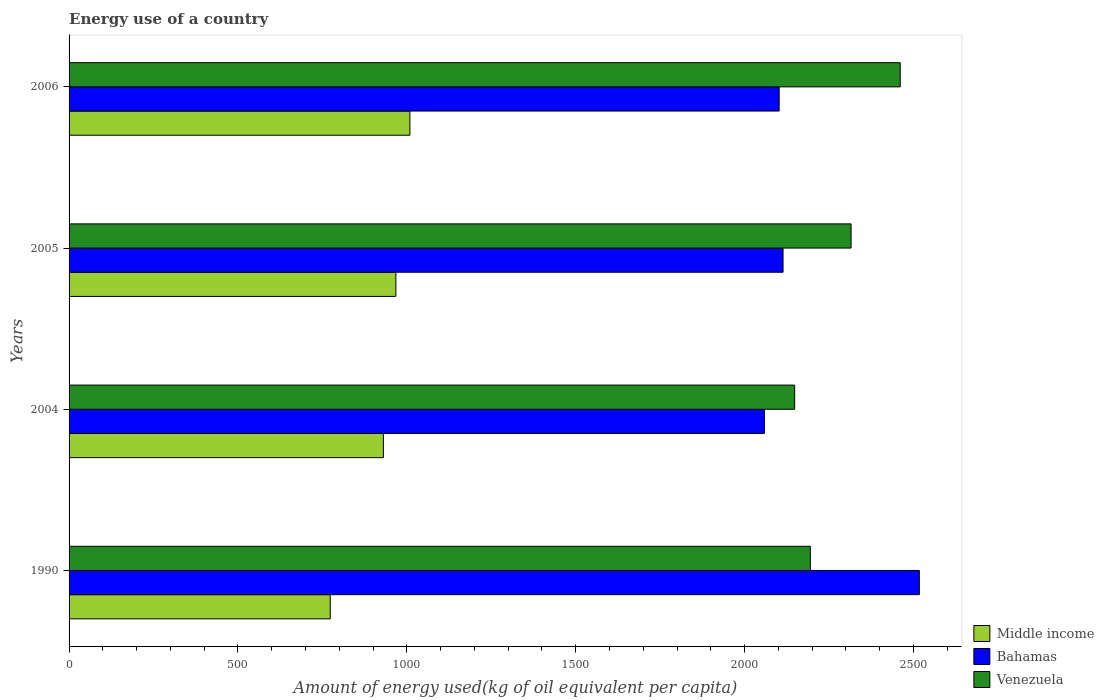What is the label of the 3rd group of bars from the top?
Your answer should be very brief. 2004. In how many cases, is the number of bars for a given year not equal to the number of legend labels?
Provide a short and direct response. 0. What is the amount of energy used in in Middle income in 1990?
Give a very brief answer. 773.25. Across all years, what is the maximum amount of energy used in in Venezuela?
Ensure brevity in your answer.  2460.81. Across all years, what is the minimum amount of energy used in in Bahamas?
Give a very brief answer. 2058.67. In which year was the amount of energy used in in Middle income maximum?
Make the answer very short. 2006. In which year was the amount of energy used in in Venezuela minimum?
Offer a terse response. 2004. What is the total amount of energy used in in Venezuela in the graph?
Your answer should be compact. 9119.11. What is the difference between the amount of energy used in in Middle income in 1990 and that in 2004?
Offer a very short reply. -157.37. What is the difference between the amount of energy used in in Venezuela in 1990 and the amount of energy used in in Bahamas in 2005?
Provide a short and direct response. 80.77. What is the average amount of energy used in in Venezuela per year?
Your answer should be compact. 2279.78. In the year 2004, what is the difference between the amount of energy used in in Middle income and amount of energy used in in Venezuela?
Offer a terse response. -1217.68. What is the ratio of the amount of energy used in in Bahamas in 1990 to that in 2006?
Ensure brevity in your answer.  1.2. Is the amount of energy used in in Bahamas in 1990 less than that in 2006?
Give a very brief answer. No. What is the difference between the highest and the second highest amount of energy used in in Middle income?
Give a very brief answer. 41.58. What is the difference between the highest and the lowest amount of energy used in in Middle income?
Offer a very short reply. 235.9. In how many years, is the amount of energy used in in Venezuela greater than the average amount of energy used in in Venezuela taken over all years?
Make the answer very short. 2. Is the sum of the amount of energy used in in Venezuela in 2004 and 2006 greater than the maximum amount of energy used in in Bahamas across all years?
Your answer should be compact. Yes. What does the 2nd bar from the top in 2005 represents?
Give a very brief answer. Bahamas. What does the 3rd bar from the bottom in 1990 represents?
Your response must be concise. Venezuela. How many bars are there?
Offer a terse response. 12. Are all the bars in the graph horizontal?
Give a very brief answer. Yes. Are the values on the major ticks of X-axis written in scientific E-notation?
Ensure brevity in your answer.  No. Does the graph contain any zero values?
Provide a succinct answer. No. Where does the legend appear in the graph?
Give a very brief answer. Bottom right. How many legend labels are there?
Offer a terse response. 3. What is the title of the graph?
Offer a very short reply. Energy use of a country. What is the label or title of the X-axis?
Your response must be concise. Amount of energy used(kg of oil equivalent per capita). What is the label or title of the Y-axis?
Offer a terse response. Years. What is the Amount of energy used(kg of oil equivalent per capita) in Middle income in 1990?
Keep it short and to the point. 773.25. What is the Amount of energy used(kg of oil equivalent per capita) of Bahamas in 1990?
Your answer should be compact. 2517.45. What is the Amount of energy used(kg of oil equivalent per capita) in Venezuela in 1990?
Make the answer very short. 2194.71. What is the Amount of energy used(kg of oil equivalent per capita) of Middle income in 2004?
Give a very brief answer. 930.62. What is the Amount of energy used(kg of oil equivalent per capita) in Bahamas in 2004?
Make the answer very short. 2058.67. What is the Amount of energy used(kg of oil equivalent per capita) of Venezuela in 2004?
Provide a short and direct response. 2148.3. What is the Amount of energy used(kg of oil equivalent per capita) of Middle income in 2005?
Offer a terse response. 967.58. What is the Amount of energy used(kg of oil equivalent per capita) of Bahamas in 2005?
Ensure brevity in your answer.  2113.94. What is the Amount of energy used(kg of oil equivalent per capita) in Venezuela in 2005?
Your response must be concise. 2315.3. What is the Amount of energy used(kg of oil equivalent per capita) in Middle income in 2006?
Offer a very short reply. 1009.15. What is the Amount of energy used(kg of oil equivalent per capita) in Bahamas in 2006?
Keep it short and to the point. 2102.44. What is the Amount of energy used(kg of oil equivalent per capita) in Venezuela in 2006?
Your response must be concise. 2460.81. Across all years, what is the maximum Amount of energy used(kg of oil equivalent per capita) in Middle income?
Offer a very short reply. 1009.15. Across all years, what is the maximum Amount of energy used(kg of oil equivalent per capita) of Bahamas?
Make the answer very short. 2517.45. Across all years, what is the maximum Amount of energy used(kg of oil equivalent per capita) in Venezuela?
Offer a terse response. 2460.81. Across all years, what is the minimum Amount of energy used(kg of oil equivalent per capita) in Middle income?
Your response must be concise. 773.25. Across all years, what is the minimum Amount of energy used(kg of oil equivalent per capita) in Bahamas?
Ensure brevity in your answer.  2058.67. Across all years, what is the minimum Amount of energy used(kg of oil equivalent per capita) in Venezuela?
Give a very brief answer. 2148.3. What is the total Amount of energy used(kg of oil equivalent per capita) of Middle income in the graph?
Ensure brevity in your answer.  3680.59. What is the total Amount of energy used(kg of oil equivalent per capita) of Bahamas in the graph?
Keep it short and to the point. 8792.49. What is the total Amount of energy used(kg of oil equivalent per capita) in Venezuela in the graph?
Make the answer very short. 9119.11. What is the difference between the Amount of energy used(kg of oil equivalent per capita) of Middle income in 1990 and that in 2004?
Offer a terse response. -157.37. What is the difference between the Amount of energy used(kg of oil equivalent per capita) in Bahamas in 1990 and that in 2004?
Give a very brief answer. 458.78. What is the difference between the Amount of energy used(kg of oil equivalent per capita) of Venezuela in 1990 and that in 2004?
Provide a succinct answer. 46.41. What is the difference between the Amount of energy used(kg of oil equivalent per capita) of Middle income in 1990 and that in 2005?
Provide a succinct answer. -194.33. What is the difference between the Amount of energy used(kg of oil equivalent per capita) in Bahamas in 1990 and that in 2005?
Offer a terse response. 403.51. What is the difference between the Amount of energy used(kg of oil equivalent per capita) of Venezuela in 1990 and that in 2005?
Your response must be concise. -120.59. What is the difference between the Amount of energy used(kg of oil equivalent per capita) in Middle income in 1990 and that in 2006?
Provide a succinct answer. -235.9. What is the difference between the Amount of energy used(kg of oil equivalent per capita) in Bahamas in 1990 and that in 2006?
Offer a very short reply. 415.01. What is the difference between the Amount of energy used(kg of oil equivalent per capita) of Venezuela in 1990 and that in 2006?
Offer a terse response. -266.1. What is the difference between the Amount of energy used(kg of oil equivalent per capita) of Middle income in 2004 and that in 2005?
Give a very brief answer. -36.96. What is the difference between the Amount of energy used(kg of oil equivalent per capita) of Bahamas in 2004 and that in 2005?
Provide a succinct answer. -55.27. What is the difference between the Amount of energy used(kg of oil equivalent per capita) in Venezuela in 2004 and that in 2005?
Give a very brief answer. -167. What is the difference between the Amount of energy used(kg of oil equivalent per capita) in Middle income in 2004 and that in 2006?
Provide a succinct answer. -78.53. What is the difference between the Amount of energy used(kg of oil equivalent per capita) of Bahamas in 2004 and that in 2006?
Provide a short and direct response. -43.77. What is the difference between the Amount of energy used(kg of oil equivalent per capita) in Venezuela in 2004 and that in 2006?
Provide a short and direct response. -312.51. What is the difference between the Amount of energy used(kg of oil equivalent per capita) in Middle income in 2005 and that in 2006?
Provide a short and direct response. -41.58. What is the difference between the Amount of energy used(kg of oil equivalent per capita) in Bahamas in 2005 and that in 2006?
Provide a short and direct response. 11.5. What is the difference between the Amount of energy used(kg of oil equivalent per capita) in Venezuela in 2005 and that in 2006?
Your answer should be compact. -145.51. What is the difference between the Amount of energy used(kg of oil equivalent per capita) of Middle income in 1990 and the Amount of energy used(kg of oil equivalent per capita) of Bahamas in 2004?
Ensure brevity in your answer.  -1285.42. What is the difference between the Amount of energy used(kg of oil equivalent per capita) of Middle income in 1990 and the Amount of energy used(kg of oil equivalent per capita) of Venezuela in 2004?
Provide a succinct answer. -1375.05. What is the difference between the Amount of energy used(kg of oil equivalent per capita) in Bahamas in 1990 and the Amount of energy used(kg of oil equivalent per capita) in Venezuela in 2004?
Provide a short and direct response. 369.15. What is the difference between the Amount of energy used(kg of oil equivalent per capita) in Middle income in 1990 and the Amount of energy used(kg of oil equivalent per capita) in Bahamas in 2005?
Your answer should be compact. -1340.69. What is the difference between the Amount of energy used(kg of oil equivalent per capita) of Middle income in 1990 and the Amount of energy used(kg of oil equivalent per capita) of Venezuela in 2005?
Offer a very short reply. -1542.05. What is the difference between the Amount of energy used(kg of oil equivalent per capita) of Bahamas in 1990 and the Amount of energy used(kg of oil equivalent per capita) of Venezuela in 2005?
Offer a very short reply. 202.15. What is the difference between the Amount of energy used(kg of oil equivalent per capita) in Middle income in 1990 and the Amount of energy used(kg of oil equivalent per capita) in Bahamas in 2006?
Keep it short and to the point. -1329.19. What is the difference between the Amount of energy used(kg of oil equivalent per capita) in Middle income in 1990 and the Amount of energy used(kg of oil equivalent per capita) in Venezuela in 2006?
Your answer should be very brief. -1687.56. What is the difference between the Amount of energy used(kg of oil equivalent per capita) of Bahamas in 1990 and the Amount of energy used(kg of oil equivalent per capita) of Venezuela in 2006?
Keep it short and to the point. 56.64. What is the difference between the Amount of energy used(kg of oil equivalent per capita) in Middle income in 2004 and the Amount of energy used(kg of oil equivalent per capita) in Bahamas in 2005?
Ensure brevity in your answer.  -1183.32. What is the difference between the Amount of energy used(kg of oil equivalent per capita) of Middle income in 2004 and the Amount of energy used(kg of oil equivalent per capita) of Venezuela in 2005?
Make the answer very short. -1384.68. What is the difference between the Amount of energy used(kg of oil equivalent per capita) of Bahamas in 2004 and the Amount of energy used(kg of oil equivalent per capita) of Venezuela in 2005?
Offer a very short reply. -256.63. What is the difference between the Amount of energy used(kg of oil equivalent per capita) in Middle income in 2004 and the Amount of energy used(kg of oil equivalent per capita) in Bahamas in 2006?
Provide a succinct answer. -1171.82. What is the difference between the Amount of energy used(kg of oil equivalent per capita) in Middle income in 2004 and the Amount of energy used(kg of oil equivalent per capita) in Venezuela in 2006?
Offer a very short reply. -1530.19. What is the difference between the Amount of energy used(kg of oil equivalent per capita) of Bahamas in 2004 and the Amount of energy used(kg of oil equivalent per capita) of Venezuela in 2006?
Make the answer very short. -402.14. What is the difference between the Amount of energy used(kg of oil equivalent per capita) of Middle income in 2005 and the Amount of energy used(kg of oil equivalent per capita) of Bahamas in 2006?
Your response must be concise. -1134.86. What is the difference between the Amount of energy used(kg of oil equivalent per capita) of Middle income in 2005 and the Amount of energy used(kg of oil equivalent per capita) of Venezuela in 2006?
Your answer should be very brief. -1493.23. What is the difference between the Amount of energy used(kg of oil equivalent per capita) in Bahamas in 2005 and the Amount of energy used(kg of oil equivalent per capita) in Venezuela in 2006?
Offer a very short reply. -346.87. What is the average Amount of energy used(kg of oil equivalent per capita) of Middle income per year?
Provide a short and direct response. 920.15. What is the average Amount of energy used(kg of oil equivalent per capita) of Bahamas per year?
Provide a short and direct response. 2198.12. What is the average Amount of energy used(kg of oil equivalent per capita) in Venezuela per year?
Your answer should be very brief. 2279.78. In the year 1990, what is the difference between the Amount of energy used(kg of oil equivalent per capita) of Middle income and Amount of energy used(kg of oil equivalent per capita) of Bahamas?
Provide a short and direct response. -1744.2. In the year 1990, what is the difference between the Amount of energy used(kg of oil equivalent per capita) in Middle income and Amount of energy used(kg of oil equivalent per capita) in Venezuela?
Offer a very short reply. -1421.46. In the year 1990, what is the difference between the Amount of energy used(kg of oil equivalent per capita) of Bahamas and Amount of energy used(kg of oil equivalent per capita) of Venezuela?
Provide a short and direct response. 322.74. In the year 2004, what is the difference between the Amount of energy used(kg of oil equivalent per capita) in Middle income and Amount of energy used(kg of oil equivalent per capita) in Bahamas?
Keep it short and to the point. -1128.05. In the year 2004, what is the difference between the Amount of energy used(kg of oil equivalent per capita) of Middle income and Amount of energy used(kg of oil equivalent per capita) of Venezuela?
Give a very brief answer. -1217.68. In the year 2004, what is the difference between the Amount of energy used(kg of oil equivalent per capita) of Bahamas and Amount of energy used(kg of oil equivalent per capita) of Venezuela?
Offer a terse response. -89.63. In the year 2005, what is the difference between the Amount of energy used(kg of oil equivalent per capita) of Middle income and Amount of energy used(kg of oil equivalent per capita) of Bahamas?
Your answer should be compact. -1146.37. In the year 2005, what is the difference between the Amount of energy used(kg of oil equivalent per capita) of Middle income and Amount of energy used(kg of oil equivalent per capita) of Venezuela?
Give a very brief answer. -1347.72. In the year 2005, what is the difference between the Amount of energy used(kg of oil equivalent per capita) of Bahamas and Amount of energy used(kg of oil equivalent per capita) of Venezuela?
Your answer should be very brief. -201.36. In the year 2006, what is the difference between the Amount of energy used(kg of oil equivalent per capita) of Middle income and Amount of energy used(kg of oil equivalent per capita) of Bahamas?
Offer a terse response. -1093.29. In the year 2006, what is the difference between the Amount of energy used(kg of oil equivalent per capita) of Middle income and Amount of energy used(kg of oil equivalent per capita) of Venezuela?
Provide a succinct answer. -1451.66. In the year 2006, what is the difference between the Amount of energy used(kg of oil equivalent per capita) in Bahamas and Amount of energy used(kg of oil equivalent per capita) in Venezuela?
Provide a short and direct response. -358.37. What is the ratio of the Amount of energy used(kg of oil equivalent per capita) in Middle income in 1990 to that in 2004?
Offer a very short reply. 0.83. What is the ratio of the Amount of energy used(kg of oil equivalent per capita) in Bahamas in 1990 to that in 2004?
Keep it short and to the point. 1.22. What is the ratio of the Amount of energy used(kg of oil equivalent per capita) of Venezuela in 1990 to that in 2004?
Ensure brevity in your answer.  1.02. What is the ratio of the Amount of energy used(kg of oil equivalent per capita) in Middle income in 1990 to that in 2005?
Your response must be concise. 0.8. What is the ratio of the Amount of energy used(kg of oil equivalent per capita) of Bahamas in 1990 to that in 2005?
Your answer should be very brief. 1.19. What is the ratio of the Amount of energy used(kg of oil equivalent per capita) of Venezuela in 1990 to that in 2005?
Give a very brief answer. 0.95. What is the ratio of the Amount of energy used(kg of oil equivalent per capita) in Middle income in 1990 to that in 2006?
Make the answer very short. 0.77. What is the ratio of the Amount of energy used(kg of oil equivalent per capita) in Bahamas in 1990 to that in 2006?
Ensure brevity in your answer.  1.2. What is the ratio of the Amount of energy used(kg of oil equivalent per capita) of Venezuela in 1990 to that in 2006?
Provide a succinct answer. 0.89. What is the ratio of the Amount of energy used(kg of oil equivalent per capita) in Middle income in 2004 to that in 2005?
Provide a succinct answer. 0.96. What is the ratio of the Amount of energy used(kg of oil equivalent per capita) in Bahamas in 2004 to that in 2005?
Make the answer very short. 0.97. What is the ratio of the Amount of energy used(kg of oil equivalent per capita) of Venezuela in 2004 to that in 2005?
Provide a short and direct response. 0.93. What is the ratio of the Amount of energy used(kg of oil equivalent per capita) of Middle income in 2004 to that in 2006?
Your answer should be compact. 0.92. What is the ratio of the Amount of energy used(kg of oil equivalent per capita) in Bahamas in 2004 to that in 2006?
Keep it short and to the point. 0.98. What is the ratio of the Amount of energy used(kg of oil equivalent per capita) in Venezuela in 2004 to that in 2006?
Give a very brief answer. 0.87. What is the ratio of the Amount of energy used(kg of oil equivalent per capita) of Middle income in 2005 to that in 2006?
Provide a succinct answer. 0.96. What is the ratio of the Amount of energy used(kg of oil equivalent per capita) of Venezuela in 2005 to that in 2006?
Your response must be concise. 0.94. What is the difference between the highest and the second highest Amount of energy used(kg of oil equivalent per capita) of Middle income?
Provide a short and direct response. 41.58. What is the difference between the highest and the second highest Amount of energy used(kg of oil equivalent per capita) in Bahamas?
Provide a short and direct response. 403.51. What is the difference between the highest and the second highest Amount of energy used(kg of oil equivalent per capita) of Venezuela?
Make the answer very short. 145.51. What is the difference between the highest and the lowest Amount of energy used(kg of oil equivalent per capita) in Middle income?
Give a very brief answer. 235.9. What is the difference between the highest and the lowest Amount of energy used(kg of oil equivalent per capita) in Bahamas?
Offer a very short reply. 458.78. What is the difference between the highest and the lowest Amount of energy used(kg of oil equivalent per capita) in Venezuela?
Make the answer very short. 312.51. 